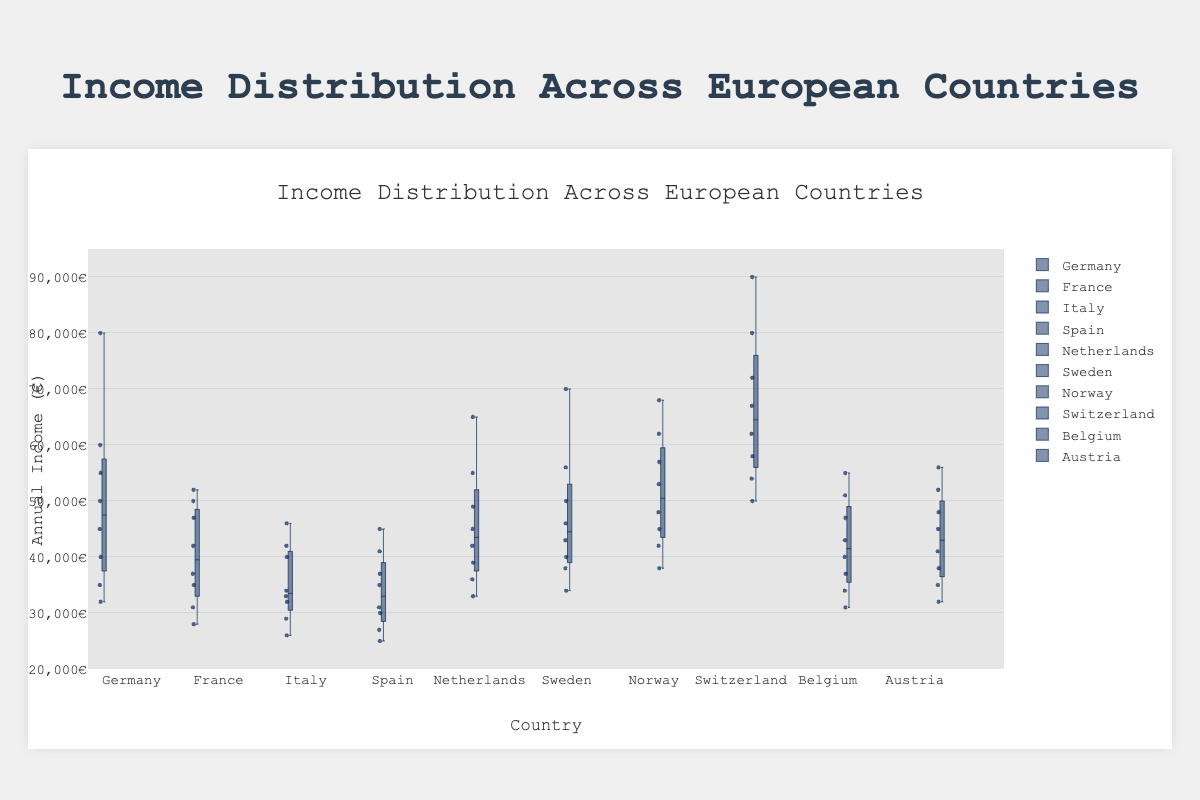Which country has the highest median income? The box plot shows that the line inside each box represents the median income. Switzerland has the highest median income, as its median line is higher than that of any other country.
Answer: Switzerland What is the range of income distribution in Spain? The range is calculated by subtracting the minimum value (the bottom whisker) from the maximum value (the top whisker). Spain's minimum income is 25000€ and its maximum income is 45000€, so the range is 45000€ - 25000€ = 20000€.
Answer: 20000€ Which country shows the highest variability in income distribution? Variability is indicated by the length of the box plus the whiskers. Switzerland has the widest spread from 50000€ to 90000€, suggesting the highest variability.
Answer: Switzerland How does the upper quartile (75th percentile) of Germany compare to the upper quartile of Austria? For both Germany and Austria, the upper quartile is represented by the top edge of the box. The box plot shows Germany's upper quartile income is higher than Austria's. Specifically, Germany's upper quartile is around 55000€, whereas Austria’s is about 48000€.
Answer: Germany has a higher upper quartile than Austria What is Sweden’s interquartile range (IQR)? The IQR is the difference between the upper quartile (75th percentile) and the lower quartile (25th percentile). For Sweden, the upper quartile is approximately 50000€ and the lower quartile is about 38000€. Thus, IQR = 50000€ - 38000€ = 12000€.
Answer: 12000€ Which country has the lowest income value? The lowest income value is indicated by the bottom whisker of each country's box plot. Spain’s whisker extends to 25000€, which is lower than the minimum values of other countries.
Answer: Spain Is there any country with outliers in the income distribution? Outliers are represented as points outside the whiskers. In the box plot, Germany has outliers, visible at the top of the plot as individual points exceeding the maximum whisker value.
Answer: Germany Which country has the smallest interquartile range (IQR)? The IQR can be visually inspected by the height of the box. Spain’s box appears shortest, indicating a smaller IQR. Therefore, Spain has the smallest IQR.
Answer: Spain Compare the median incomes of the Netherlands and Belgium. Which is higher? The median income is shown by the line inside each box. The Netherlands’ median line is higher than Belgium’s, indicating that the median income in the Netherlands is higher.
Answer: Netherlands What income values represent the 25th percentile for Italy? The 25th percentile is indicated by the bottom edge of the box. For Italy, this value is around 29000€.
Answer: 29000€ 